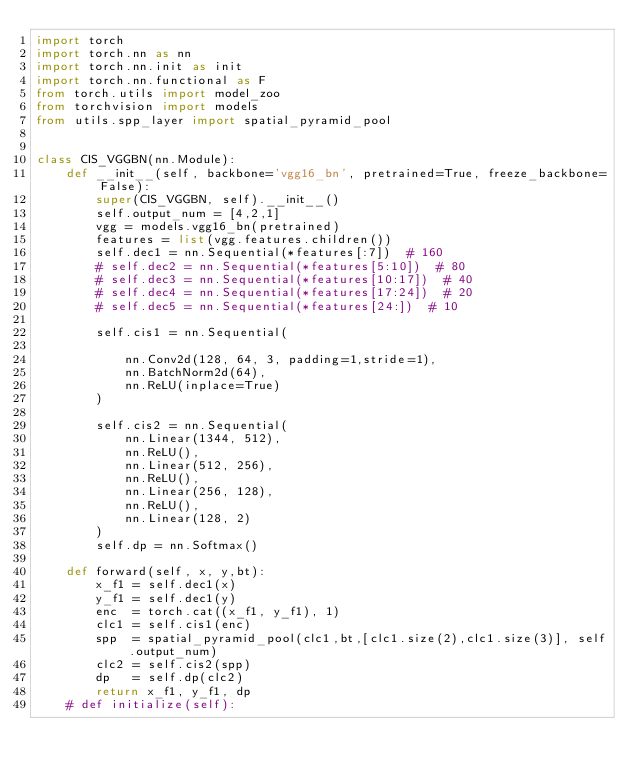Convert code to text. <code><loc_0><loc_0><loc_500><loc_500><_Python_>import torch
import torch.nn as nn
import torch.nn.init as init
import torch.nn.functional as F
from torch.utils import model_zoo
from torchvision import models
from utils.spp_layer import spatial_pyramid_pool


class CIS_VGGBN(nn.Module):
    def __init__(self, backbone='vgg16_bn', pretrained=True, freeze_backbone=False):
        super(CIS_VGGBN, self).__init__()
        self.output_num = [4,2,1]
        vgg = models.vgg16_bn(pretrained)
        features = list(vgg.features.children())
        self.dec1 = nn.Sequential(*features[:7])  # 160
        # self.dec2 = nn.Sequential(*features[5:10])  # 80
        # self.dec3 = nn.Sequential(*features[10:17])  # 40
        # self.dec4 = nn.Sequential(*features[17:24])  # 20
        # self.dec5 = nn.Sequential(*features[24:])  # 10

        self.cis1 = nn.Sequential(

            nn.Conv2d(128, 64, 3, padding=1,stride=1),
            nn.BatchNorm2d(64),
            nn.ReLU(inplace=True)
        )
   
        self.cis2 = nn.Sequential(
            nn.Linear(1344, 512),
            nn.ReLU(),
            nn.Linear(512, 256),
            nn.ReLU(),
            nn.Linear(256, 128),
            nn.ReLU(),
            nn.Linear(128, 2)
        )
        self.dp = nn.Softmax()
     
    def forward(self, x, y,bt):
        x_f1 = self.dec1(x)
        y_f1 = self.dec1(y)
        enc  = torch.cat((x_f1, y_f1), 1)
        clc1 = self.cis1(enc)
        spp  = spatial_pyramid_pool(clc1,bt,[clc1.size(2),clc1.size(3)], self.output_num)
        clc2 = self.cis2(spp)
        dp   = self.dp(clc2)
        return x_f1, y_f1, dp
    # def initialize(self):</code> 